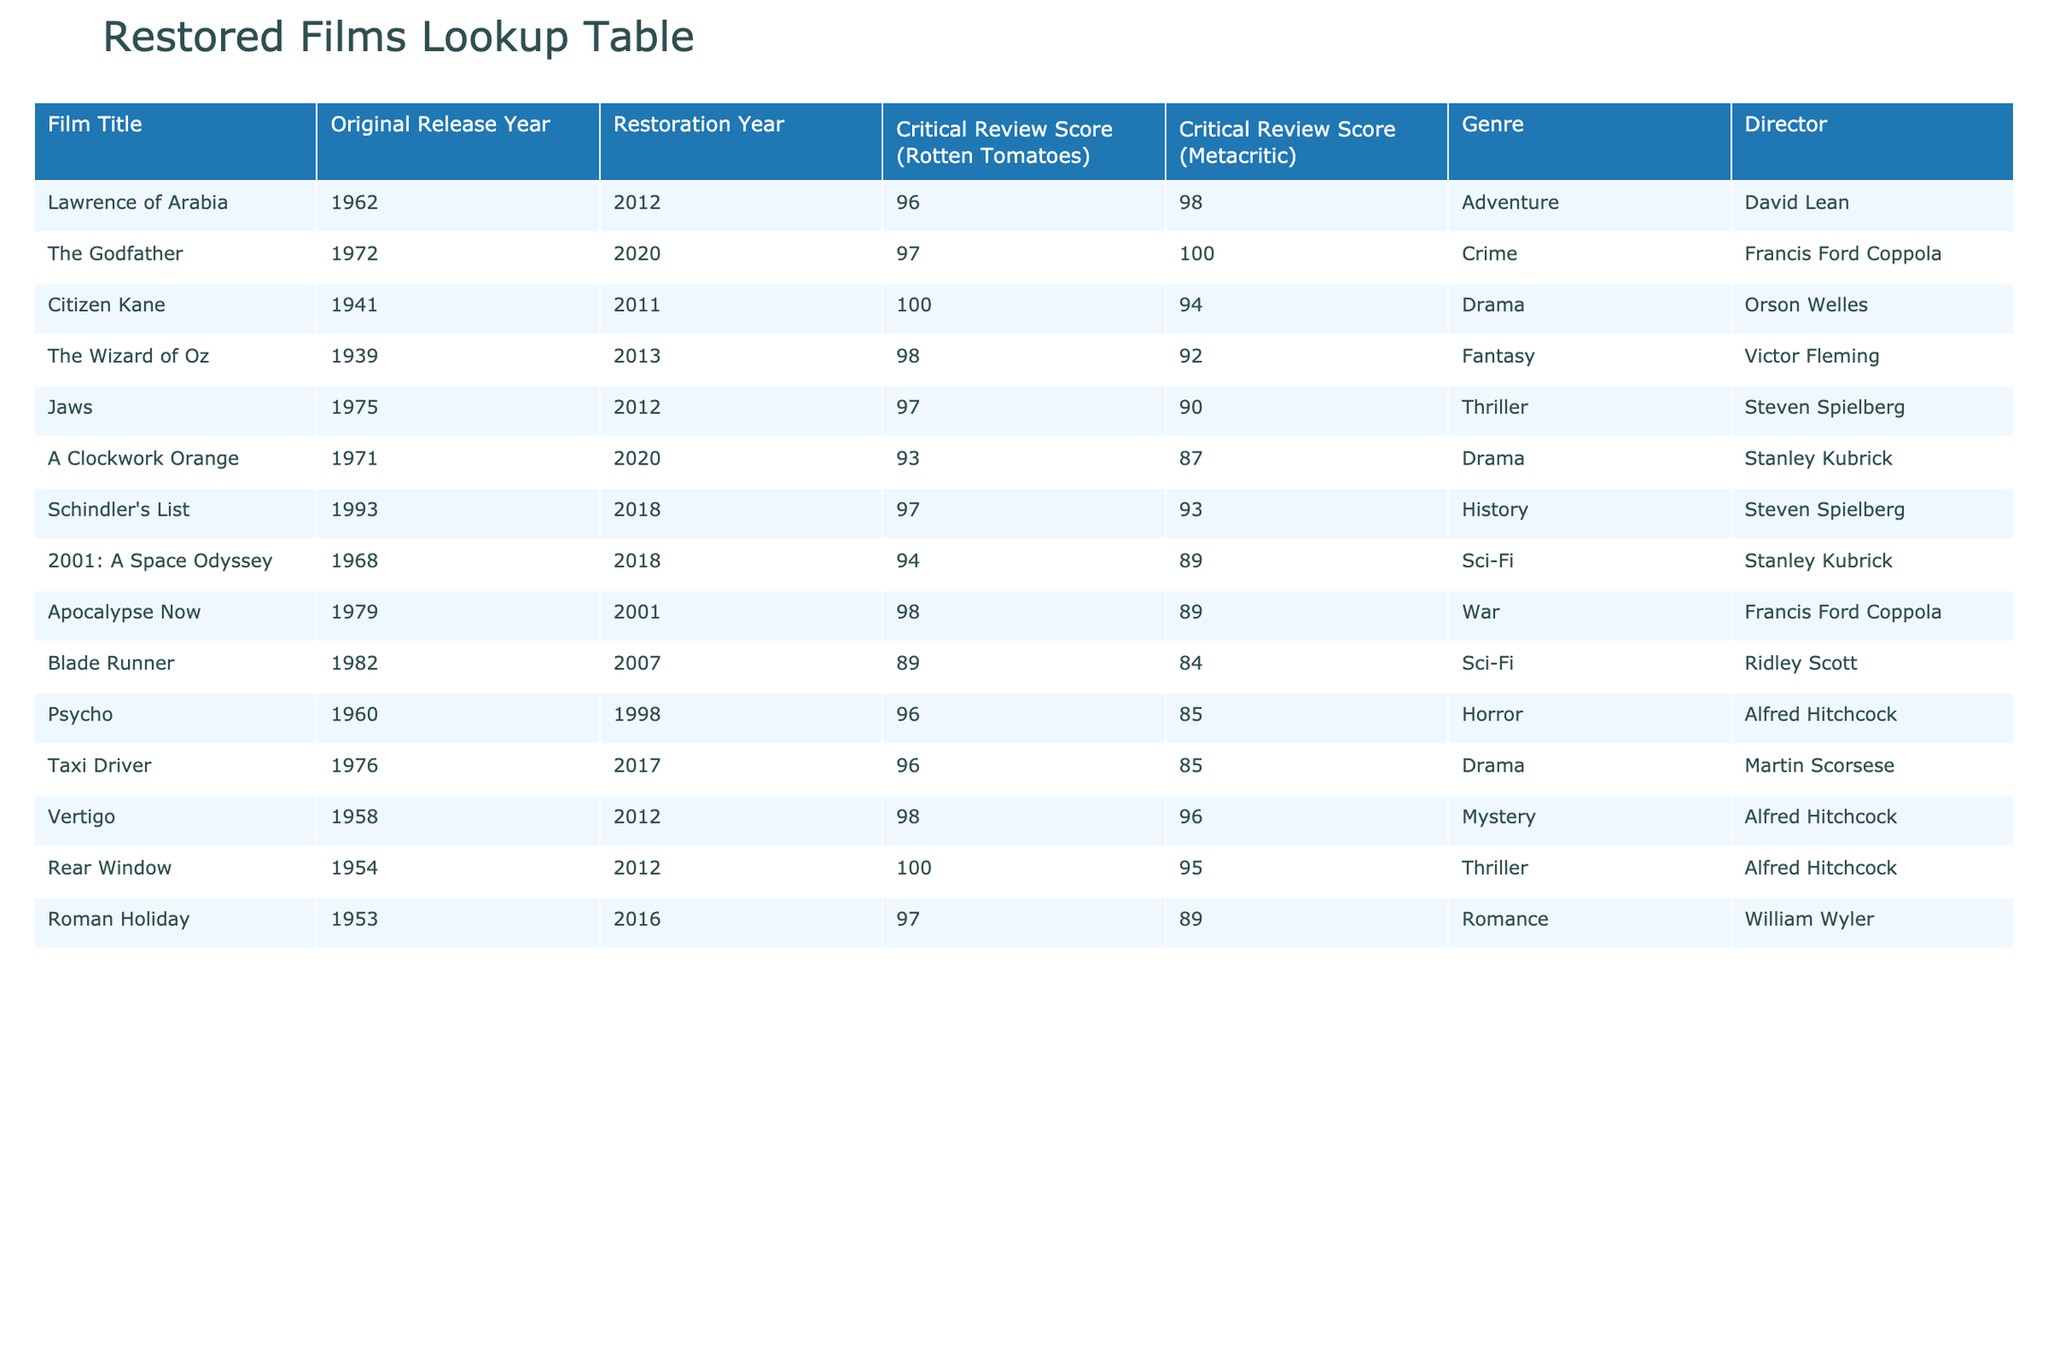What is the critical review score of "Citizen Kane" on Rotten Tomatoes? The table lists "Citizen Kane" under Film Title with a corresponding critical review score on Rotten Tomatoes of 100%.
Answer: 100% Which film from 2018 has the highest Rotten Tomatoes score? The films released in 2018 according to the table are "Schindler's List" and "2001: A Space Odyssey." "Schindler's List" has a score of 97% while "2001: A Space Odyssey" has a score of 94%. Therefore, "Schindler's List" has the highest Rotten Tomatoes score in 2018.
Answer: Schindler's List Is the critical review score of "The Wizard of Oz" higher on Rotten Tomatoes than on Metacritic? "The Wizard of Oz" has a Rotten Tomatoes score of 98% and a Metacritic score of 92%. Since 98% is higher than 92%, the answer is yes.
Answer: Yes What is the average Rotten Tomatoes score for films directed by Alfred Hitchcock? The table lists three films directed by Alfred Hitchcock with Rotten Tomatoes scores: "Psycho" (96%), "Vertigo" (98%), and "Rear Window" (100%). The average is calculated as (96 + 98 + 100) / 3 = 98.
Answer: 98% Which film has the lowest Metacritic score and what is it? Looking at all the films in the table, "Blade Runner" has the lowest Metacritic score of 84%.
Answer: Blade Runner, 84% How many films in the table were restored in the year 2012? The films restored in 2012 are "Lawrence of Arabia," "Jaws," "Vertigo," and "Rear Window," which totals four films.
Answer: 4 What is the difference between the highest and lowest Metacritic scores in the table? The highest Metacritic score is 100% for "The Godfather," and the lowest is 84% for "Blade Runner." The difference is 100% - 84% = 16%.
Answer: 16% Which genre has the highest average Rotten Tomatoes score based on the table? Calculate the average Rotten Tomatoes scores by genre: Adventure (96%), Crime (97%), Drama (95%), Fantasy (98%), Thriller (97%), War (98%), Sci-Fi (94%), Horror (96%), Mystery (98%), Romance (97%). The highest average is for Fantasy at 98%.
Answer: Fantasy Does "A Clockwork Orange" have a higher Rotten Tomatoes score than "Taxi Driver"? "A Clockwork Orange" has a Rotten Tomatoes score of 93%, while "Taxi Driver" has a score of 96%. Since 93% is less than 96%, the answer is no.
Answer: No 